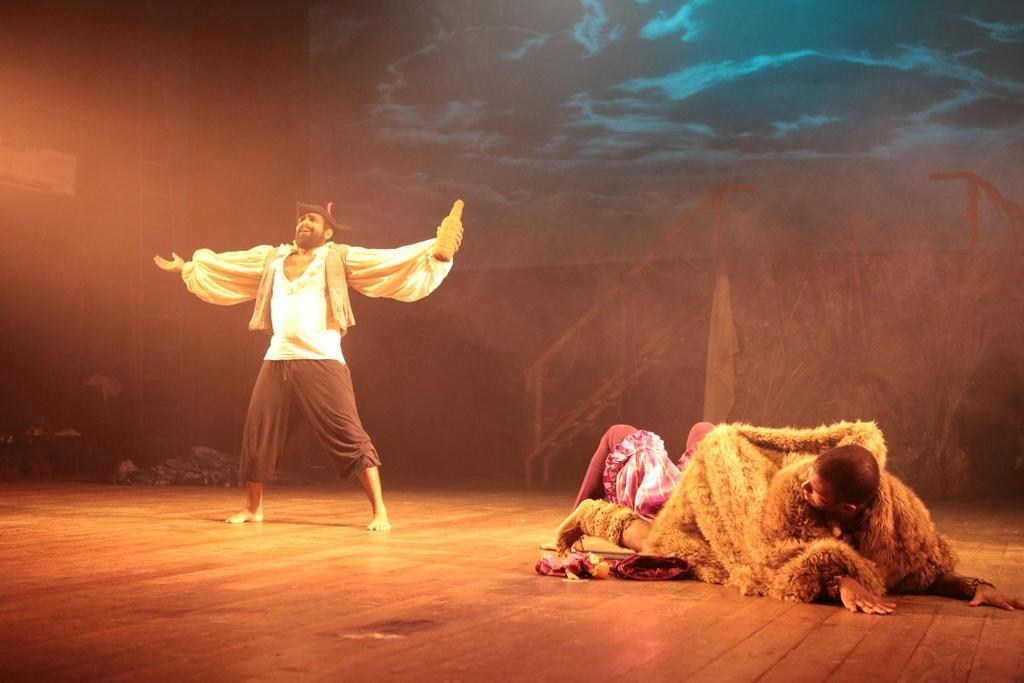Can you describe this image briefly? This is a picture of a stage performance. On the right there are two people, on the stage. On the left there is a person standing. In the background there are staircase, clothes, ladder and a scenery board. 